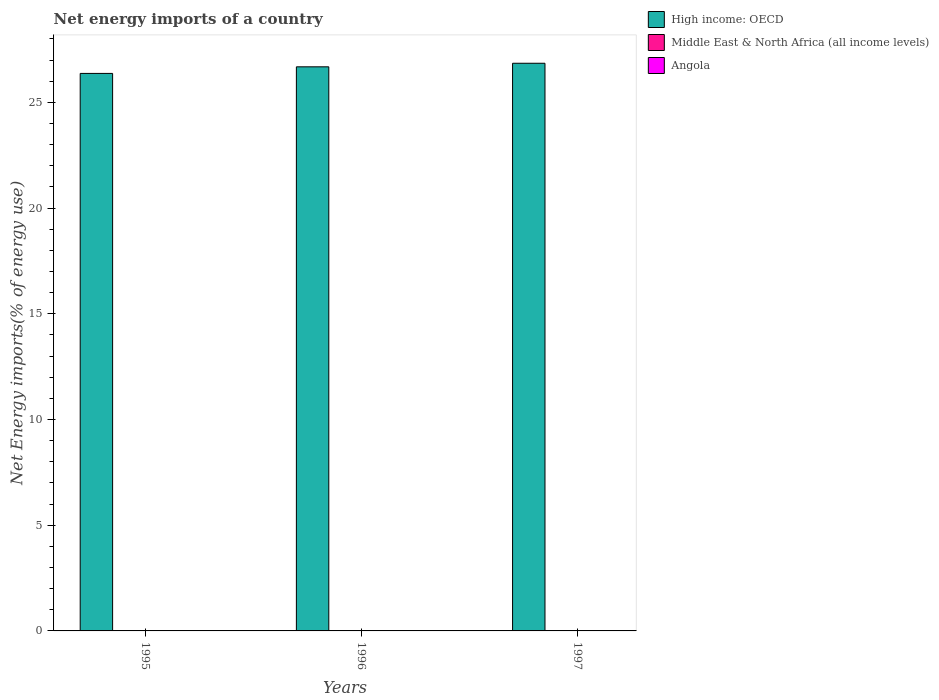Are the number of bars per tick equal to the number of legend labels?
Provide a short and direct response. No. How many bars are there on the 2nd tick from the right?
Provide a succinct answer. 1. In how many cases, is the number of bars for a given year not equal to the number of legend labels?
Provide a short and direct response. 3. What is the net energy imports in High income: OECD in 1996?
Make the answer very short. 26.68. Across all years, what is the maximum net energy imports in High income: OECD?
Your response must be concise. 26.85. Across all years, what is the minimum net energy imports in High income: OECD?
Provide a short and direct response. 26.37. In which year was the net energy imports in High income: OECD maximum?
Make the answer very short. 1997. What is the total net energy imports in Middle East & North Africa (all income levels) in the graph?
Offer a very short reply. 0. What is the difference between the net energy imports in High income: OECD in 1995 and that in 1996?
Provide a short and direct response. -0.31. What is the difference between the net energy imports in Middle East & North Africa (all income levels) in 1996 and the net energy imports in Angola in 1995?
Provide a short and direct response. 0. What is the average net energy imports in Angola per year?
Keep it short and to the point. 0. In how many years, is the net energy imports in Angola greater than 5 %?
Give a very brief answer. 0. What is the ratio of the net energy imports in High income: OECD in 1996 to that in 1997?
Keep it short and to the point. 0.99. What is the difference between the highest and the second highest net energy imports in High income: OECD?
Your answer should be very brief. 0.17. What is the difference between the highest and the lowest net energy imports in High income: OECD?
Your answer should be very brief. 0.48. Is the sum of the net energy imports in High income: OECD in 1995 and 1996 greater than the maximum net energy imports in Middle East & North Africa (all income levels) across all years?
Offer a terse response. Yes. How many bars are there?
Offer a terse response. 3. How many years are there in the graph?
Your answer should be very brief. 3. Are the values on the major ticks of Y-axis written in scientific E-notation?
Offer a very short reply. No. Does the graph contain any zero values?
Offer a very short reply. Yes. Does the graph contain grids?
Give a very brief answer. No. Where does the legend appear in the graph?
Your response must be concise. Top right. How many legend labels are there?
Offer a very short reply. 3. What is the title of the graph?
Keep it short and to the point. Net energy imports of a country. Does "Malaysia" appear as one of the legend labels in the graph?
Offer a terse response. No. What is the label or title of the X-axis?
Your answer should be very brief. Years. What is the label or title of the Y-axis?
Provide a succinct answer. Net Energy imports(% of energy use). What is the Net Energy imports(% of energy use) of High income: OECD in 1995?
Make the answer very short. 26.37. What is the Net Energy imports(% of energy use) of Middle East & North Africa (all income levels) in 1995?
Ensure brevity in your answer.  0. What is the Net Energy imports(% of energy use) of Angola in 1995?
Offer a very short reply. 0. What is the Net Energy imports(% of energy use) of High income: OECD in 1996?
Provide a succinct answer. 26.68. What is the Net Energy imports(% of energy use) in Middle East & North Africa (all income levels) in 1996?
Your answer should be very brief. 0. What is the Net Energy imports(% of energy use) in High income: OECD in 1997?
Your response must be concise. 26.85. What is the Net Energy imports(% of energy use) of Middle East & North Africa (all income levels) in 1997?
Your response must be concise. 0. What is the Net Energy imports(% of energy use) of Angola in 1997?
Make the answer very short. 0. Across all years, what is the maximum Net Energy imports(% of energy use) of High income: OECD?
Provide a short and direct response. 26.85. Across all years, what is the minimum Net Energy imports(% of energy use) of High income: OECD?
Offer a very short reply. 26.37. What is the total Net Energy imports(% of energy use) in High income: OECD in the graph?
Provide a succinct answer. 79.91. What is the total Net Energy imports(% of energy use) of Middle East & North Africa (all income levels) in the graph?
Your answer should be compact. 0. What is the difference between the Net Energy imports(% of energy use) in High income: OECD in 1995 and that in 1996?
Keep it short and to the point. -0.31. What is the difference between the Net Energy imports(% of energy use) in High income: OECD in 1995 and that in 1997?
Provide a short and direct response. -0.48. What is the difference between the Net Energy imports(% of energy use) in High income: OECD in 1996 and that in 1997?
Offer a terse response. -0.17. What is the average Net Energy imports(% of energy use) in High income: OECD per year?
Give a very brief answer. 26.64. What is the average Net Energy imports(% of energy use) in Middle East & North Africa (all income levels) per year?
Keep it short and to the point. 0. What is the ratio of the Net Energy imports(% of energy use) in High income: OECD in 1995 to that in 1996?
Keep it short and to the point. 0.99. What is the ratio of the Net Energy imports(% of energy use) in High income: OECD in 1995 to that in 1997?
Your answer should be very brief. 0.98. What is the ratio of the Net Energy imports(% of energy use) of High income: OECD in 1996 to that in 1997?
Offer a very short reply. 0.99. What is the difference between the highest and the second highest Net Energy imports(% of energy use) in High income: OECD?
Keep it short and to the point. 0.17. What is the difference between the highest and the lowest Net Energy imports(% of energy use) of High income: OECD?
Your response must be concise. 0.48. 